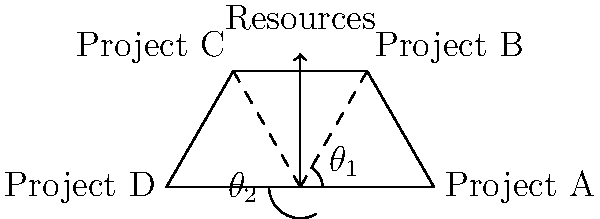In the force diagram shown, four software projects (A, B, C, and D) are represented as vectors from a central point. The length of each vector corresponds to the project's resource requirements. If the total available resources are represented by the vertical arrow, how should the angles $\theta_1$ and $\theta_2$ be adjusted to optimize resource allocation across all projects while maintaining the given vector lengths? To optimize resource allocation across all projects while maintaining the given vector lengths, we need to follow these steps:

1. Understand the current situation:
   - The vertical arrow represents total available resources.
   - Each project (A, B, C, D) is represented by a vector, with its length indicating resource requirements.
   - Angles $\theta_1$ and $\theta_2$ determine the distribution of resources among projects.

2. Recognize the goal:
   - We want to balance resources across all projects optimally.
   - The sum of vertical components of all vectors should equal the total available resources.

3. Apply the principle of vector resolution:
   - The vertical component of each vector represents the resources allocated to that project.
   - We can express this mathematically as:
     $$R_{\text{total}} = R_A \sin(90°) + R_B \sin(\theta_1) + R_C \sin(\theta_2) + R_D \sin(90°)$$
   Where $R_{\text{total}}$ is the total available resources, and $R_A$, $R_B$, $R_C$, and $R_D$ are the resource requirements for each project.

4. Optimize the angles:
   - Adjust $\theta_1$ and $\theta_2$ to maximize the sum of vertical components.
   - This is achieved when the rate of change of the sum with respect to each angle is equal:
     $$R_B \cos(\theta_1) = R_C \cos(\theta_2)$$

5. Consider practical constraints:
   - Ensure that no project is completely neglected (i.e., $\theta_1$ and $\theta_2$ should not be 0° or 180°).
   - Take into account project priorities and dependencies.

6. Iterate and fine-tune:
   - Adjust angles incrementally and recalculate resource distribution.
   - Aim for a balance that satisfies both mathematical optimization and practical business needs.
Answer: Adjust $\theta_1$ and $\theta_2$ to satisfy $R_B \cos(\theta_1) = R_C \cos(\theta_2)$ while maximizing $R_A + R_B \sin(\theta_1) + R_C \sin(\theta_2) + R_D$. 